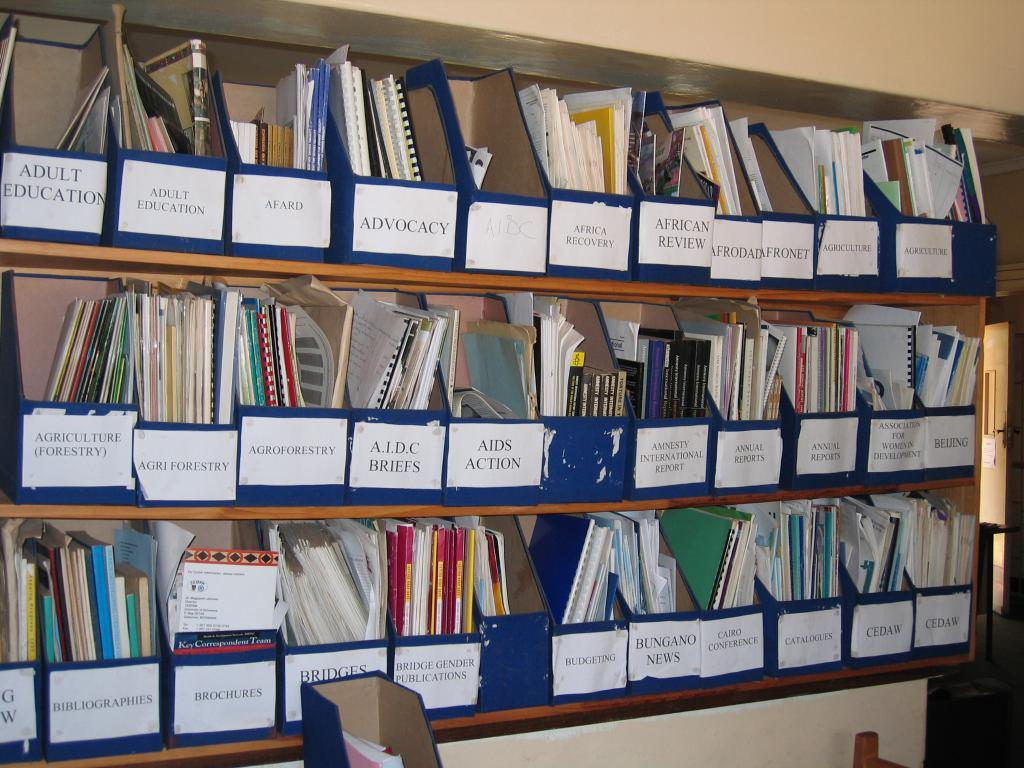<image>
Present a compact description of the photo's key features. A very cluttered book shelf has a section for Advocacy and Africa Recovery 